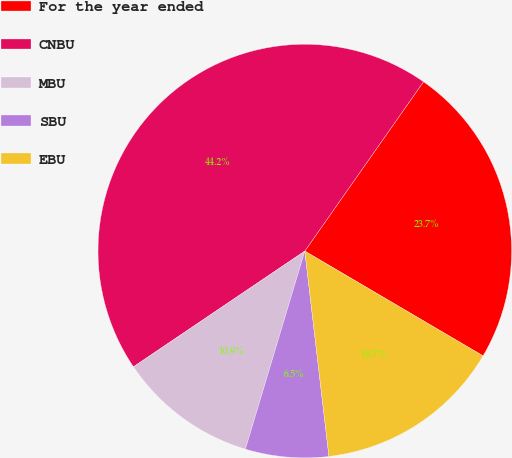Convert chart. <chart><loc_0><loc_0><loc_500><loc_500><pie_chart><fcel>For the year ended<fcel>CNBU<fcel>MBU<fcel>SBU<fcel>EBU<nl><fcel>23.73%<fcel>44.19%<fcel>10.91%<fcel>6.5%<fcel>14.68%<nl></chart> 